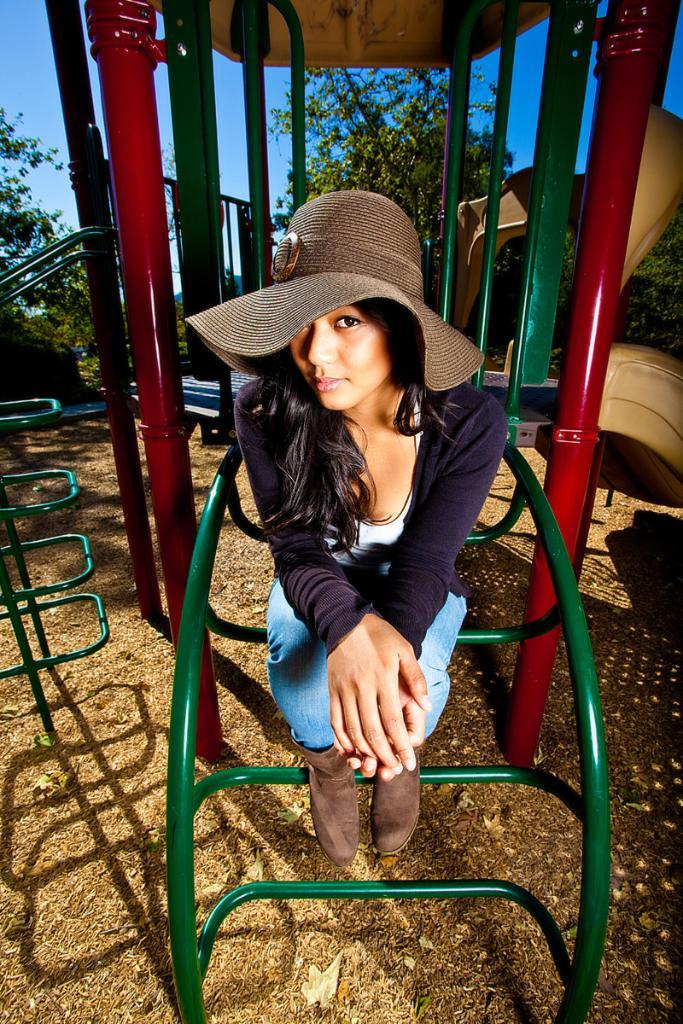Who is the main subject in the image? There is a woman in the image. What setting is depicted in the image? The image appears to depict a playground. What type of natural environment is visible in the background of the image? There are trees in the background of the image. What is visible in the sky in the background of the image? The sky is visible in the background of the image. How does the woman's digestion process appear in the image? There is no indication of the woman's digestion process in the image. What type of maid is present in the image? There is no maid present in the image. 